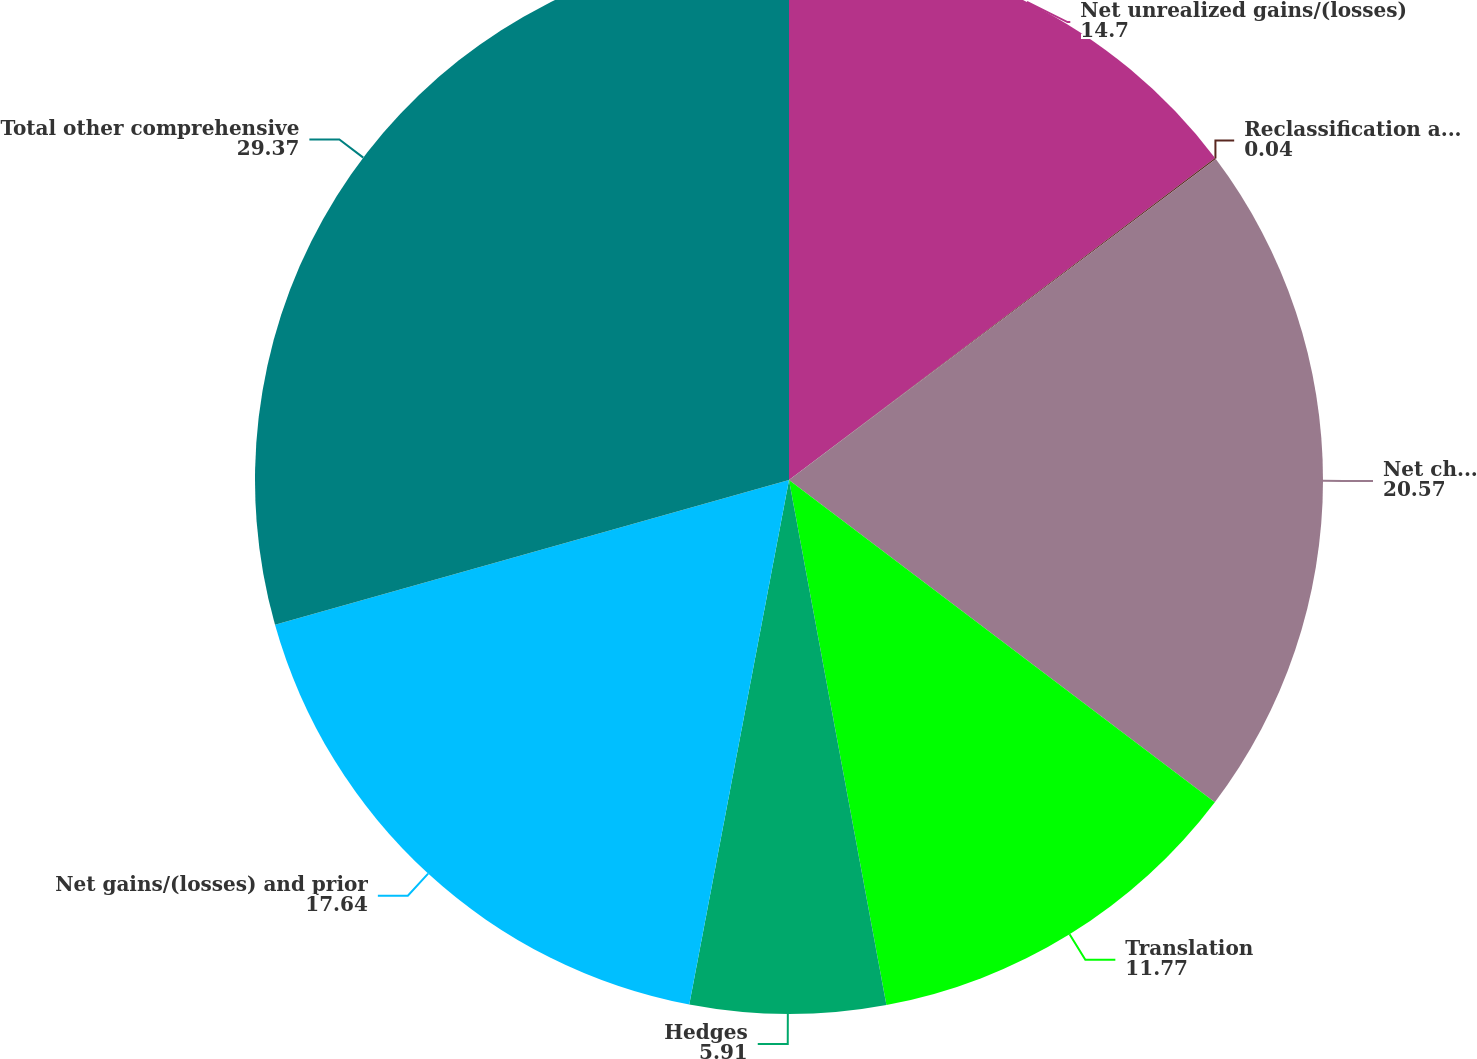Convert chart. <chart><loc_0><loc_0><loc_500><loc_500><pie_chart><fcel>Net unrealized gains/(losses)<fcel>Reclassification adjustment<fcel>Net change<fcel>Translation<fcel>Hedges<fcel>Net gains/(losses) and prior<fcel>Total other comprehensive<nl><fcel>14.7%<fcel>0.04%<fcel>20.57%<fcel>11.77%<fcel>5.91%<fcel>17.64%<fcel>29.37%<nl></chart> 